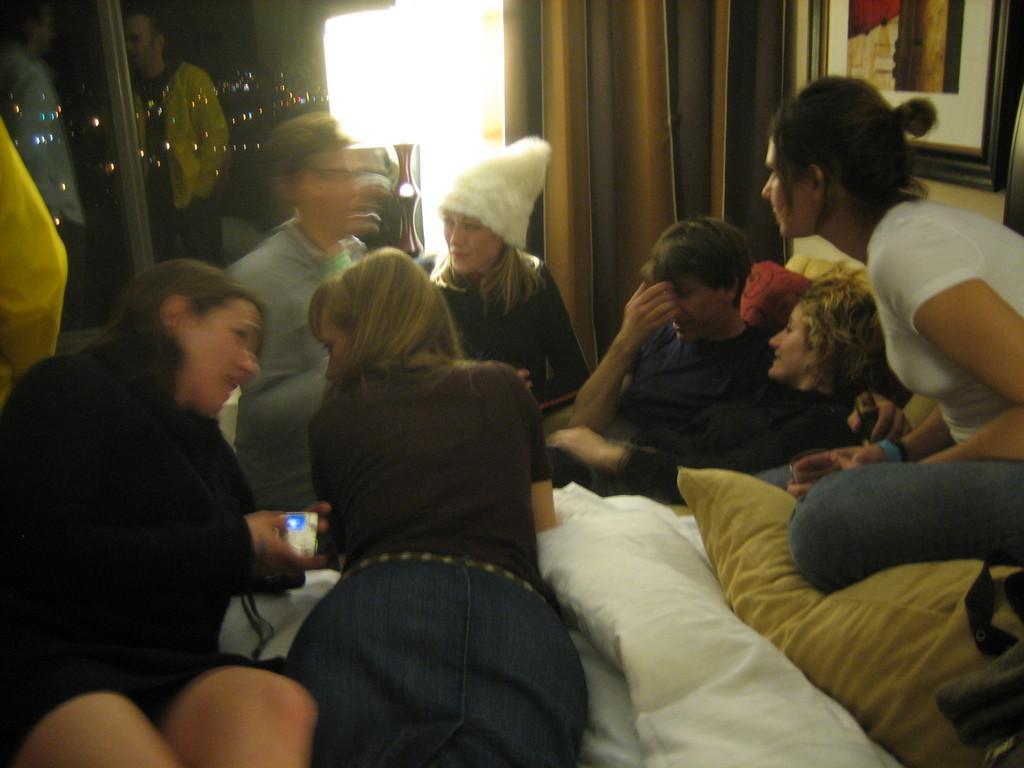Could you give a brief overview of what you see in this image? In this image there are group of persons lying on the blankets and pillows on the bed, and at the background there is curtain, lamp, frame attached to wall. 